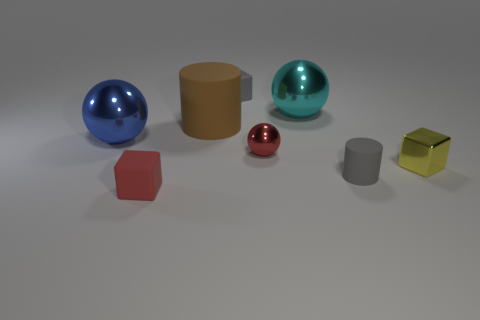There is a gray thing in front of the blue object; what is its shape?
Your answer should be very brief. Cylinder. What is the material of the red ball?
Your response must be concise. Metal. What is the color of the matte object that is the same size as the blue metallic sphere?
Your answer should be very brief. Brown. Do the cyan object and the large brown rubber object have the same shape?
Your answer should be compact. No. What is the cube that is both to the left of the gray cylinder and on the right side of the large brown matte cylinder made of?
Make the answer very short. Rubber. What size is the cyan metal sphere?
Make the answer very short. Large. There is another big metal object that is the same shape as the large blue shiny thing; what color is it?
Provide a succinct answer. Cyan. Is there anything else that has the same color as the tiny rubber cylinder?
Provide a short and direct response. Yes. Do the gray object that is on the left side of the small sphere and the cube that is in front of the small cylinder have the same size?
Make the answer very short. Yes. Is the number of red blocks that are behind the small red block the same as the number of matte objects that are behind the big cyan object?
Give a very brief answer. No. 